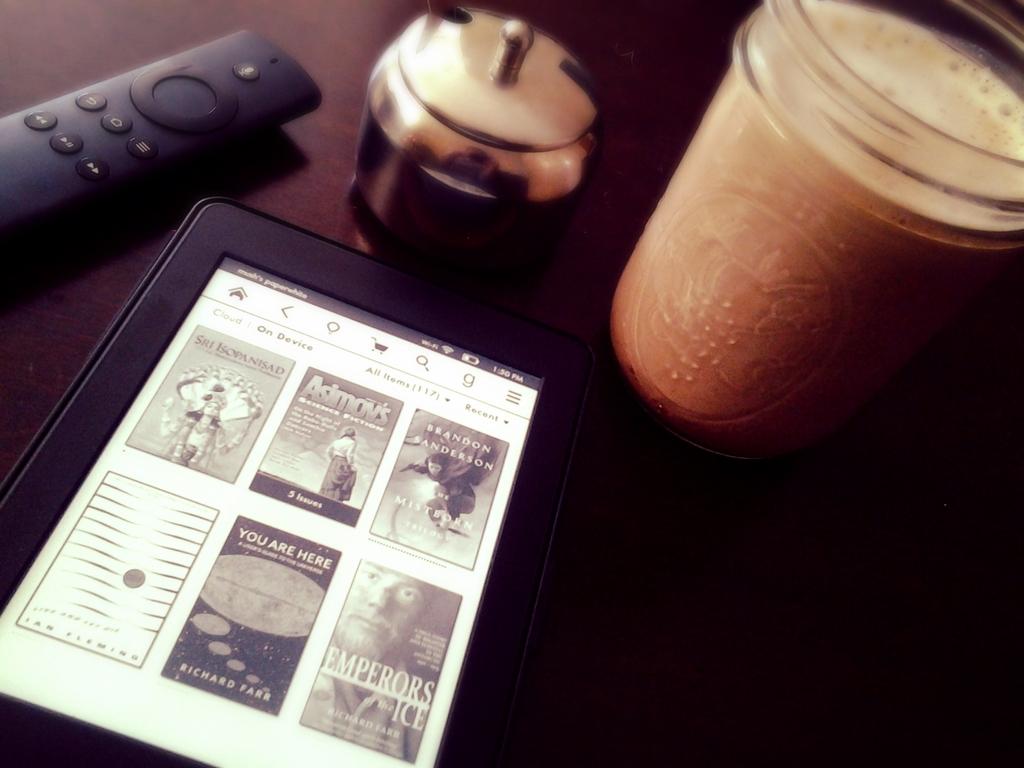What is the title of the middle book on the top row?
Offer a very short reply. Asimov's science fiction. What is the title of the book in the bottom corner?
Keep it short and to the point. Emperors of the ice. 